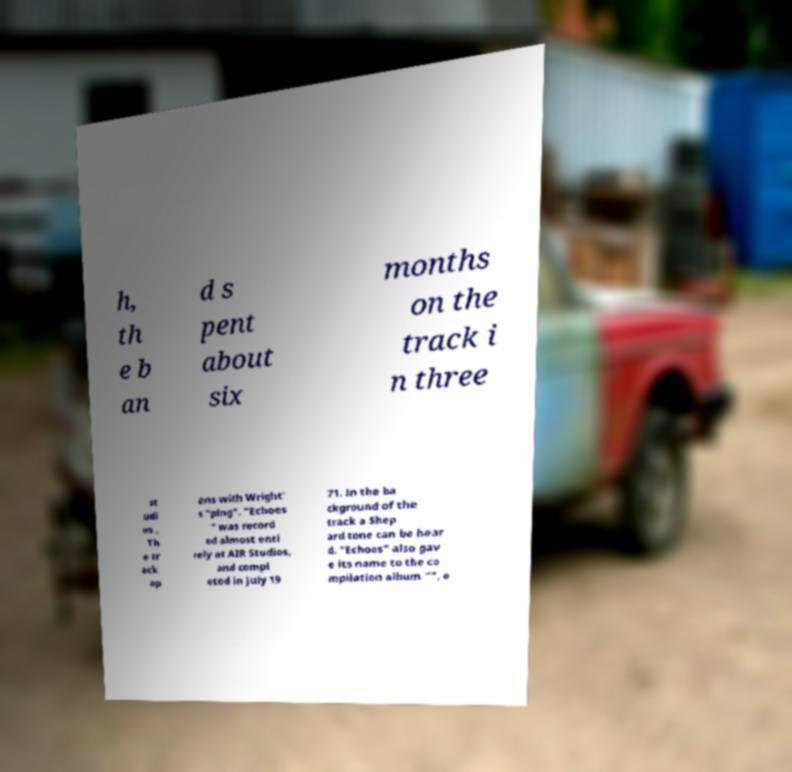Can you accurately transcribe the text from the provided image for me? h, th e b an d s pent about six months on the track i n three st udi os . Th e tr ack op ens with Wright' s "ping". "Echoes " was record ed almost enti rely at AIR Studios, and compl eted in July 19 71. In the ba ckground of the track a Shep ard tone can be hear d. "Echoes" also gav e its name to the co mpilation album "", o 